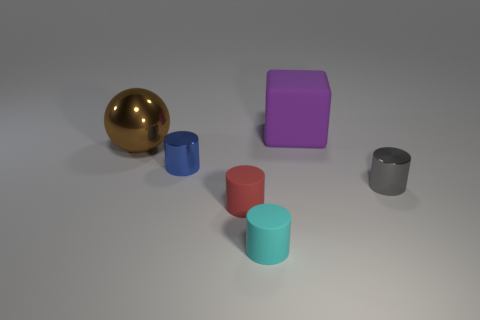Subtract all small cyan matte cylinders. How many cylinders are left? 3 Subtract all red cylinders. How many cylinders are left? 3 Subtract 1 spheres. How many spheres are left? 0 Add 4 small metal cylinders. How many objects exist? 10 Subtract all blocks. How many objects are left? 5 Add 5 cyan matte cylinders. How many cyan matte cylinders are left? 6 Add 4 matte blocks. How many matte blocks exist? 5 Subtract 0 green cubes. How many objects are left? 6 Subtract all blue spheres. Subtract all green cubes. How many spheres are left? 1 Subtract all gray blocks. How many gray spheres are left? 0 